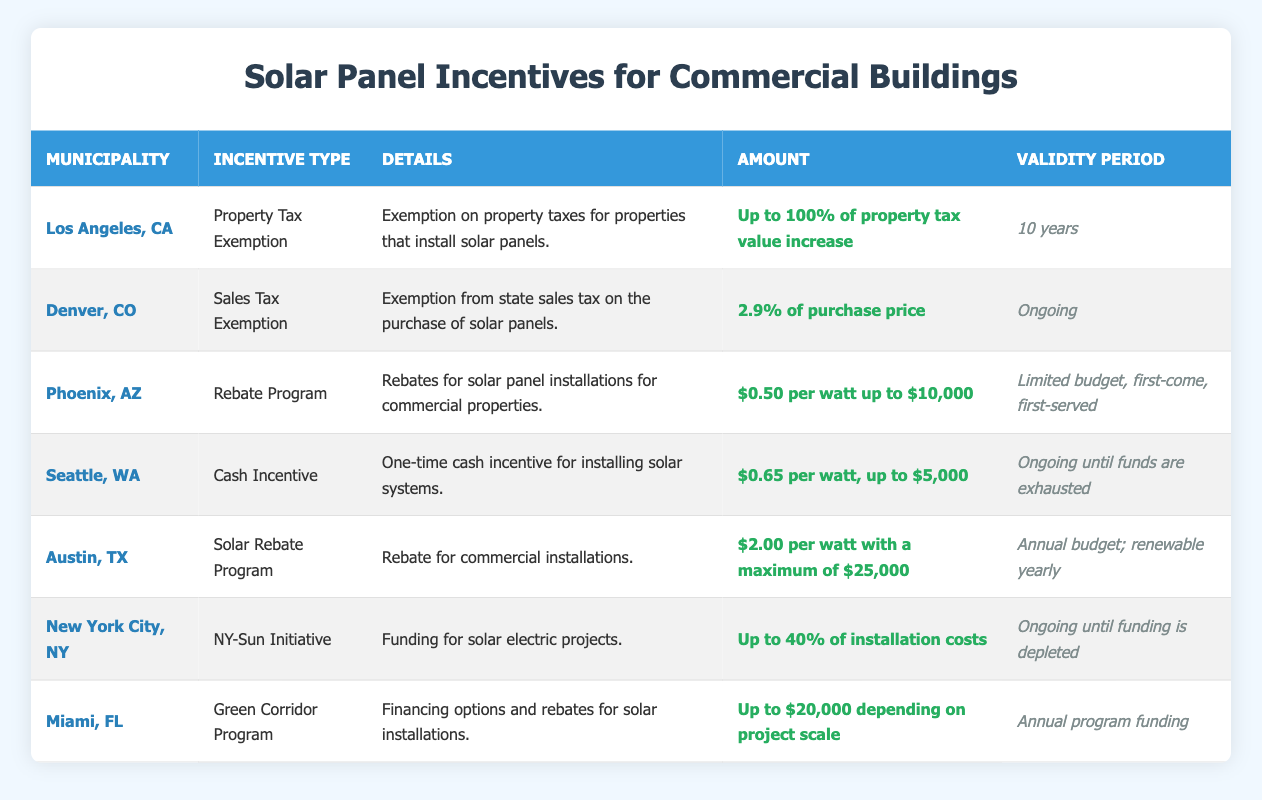What is the incentive type for Los Angeles, CA? The table states that Los Angeles, CA offers a Property Tax Exemption as the incentive type for solar panel installations.
Answer: Property Tax Exemption What is the validity period for the Denver, CO sales tax exemption? The table shows that the validity period for the sales tax exemption in Denver, CO is ongoing.
Answer: Ongoing How much can a commercial property in Austin, TX receive from the solar rebate program? The solar rebate program in Austin, TX offers a maximum amount of $25,000 for commercial installations, as mentioned in the table.
Answer: $25,000 Is there a cash incentive for solar installations in Seattle, WA? Yes, the table confirms that there is a cash incentive available for solar installations in Seattle, WA.
Answer: Yes Which municipality has the highest potential rebate amount? By comparing the amounts, Miami, FL has a potential rebate of up to $20,000, while other municipalities have lower limits, such as New York City's up to 40% of installation costs, which may vary based on total installation. However, $20,000 is a specific maximum mentioned for Miami, which makes it the highest defined amount.
Answer: Miami, FL What would be the total incentive amount for a solar installation of 15,000 watts in Phoenix, AZ? In Phoenix, AZ, the incentive is $0.50 per watt with a cap of $10,000. For 15,000 watts, the calculation would be 15,000 watts * $0.50 = $7,500, which is below the cap of $10,000; therefore, the total incentive would be $7,500.
Answer: $7,500 Does the NY-Sun Initiative in New York City have a specified validity period? The table indicates that the NY-Sun Initiative has an ongoing validity period until funding is depleted.
Answer: Yes If a commercial building in Seattle, WA receives the maximum cash incentive for a solar installation, how much would it be for a 10,000-watt system? The cash incentive in Seattle, WA is $0.65 per watt, with a maximum of $5,000. For a 10,000-watt system, the calculation would be 10,000 watts * $0.65 = $6,500, which exceeds the cap of $5,000; thus, the total would be capped at $5,000.
Answer: $5,000 Which municipalities provide an ongoing program for solar installation incentives? Reviewing the table, Denver, CO (Sales Tax Exemption), Seattle, WA (Cash Incentive), New York City, NY (NY-Sun Initiative), and Phoenix, AZ (unlimited budget, first-come, first-served) have programs that are ongoing.
Answer: Denver, CO; Seattle, WA; New York City, NY; Phoenix, AZ 